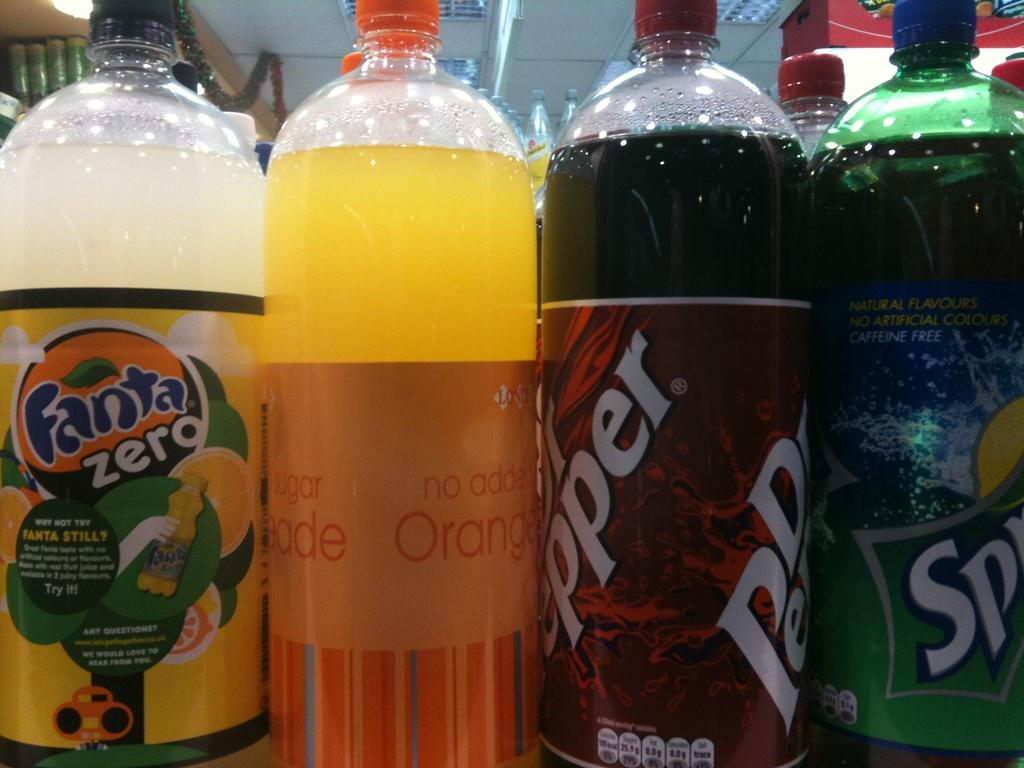<image>
Write a terse but informative summary of the picture. A group of soda bottles are close to each other including Sprite, and Dr. Pepper. 